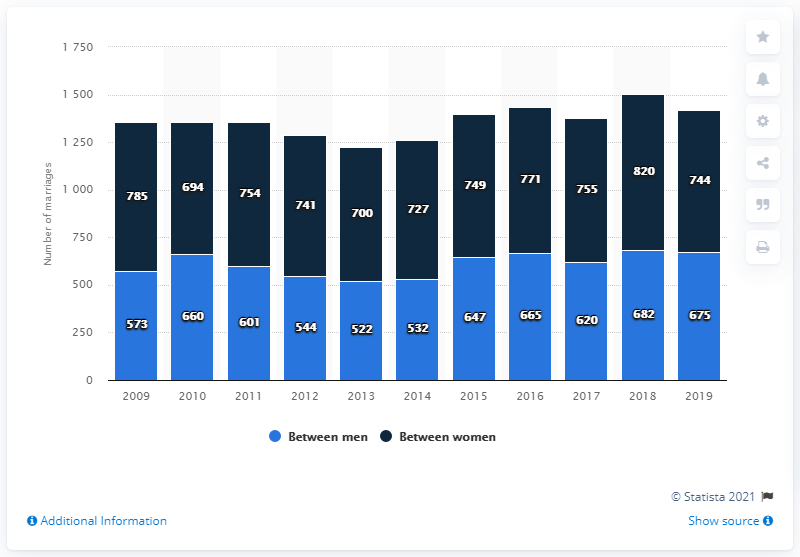Can you explain what the chart is showing? Certainly! The chart depicts the number of marriages between men and between women for each year from 2009 to 2019. The blue sections represent marriages between men, and the dark sections represent marriages between women. You can see trends such as a general increase in the number of marriages among both groups over time. What has been the general trend for marriages between men and marriages between women? From the chart, there appears to be an increasing trend in the number of marriages both between men and between women from 2009 to 2019. However, there are some fluctuations; for example, there was a slight dip in marriages between men from 2010 to 2011 and another from 2013 to 2014. Overall, the number peaked in 2018 for both groups. 